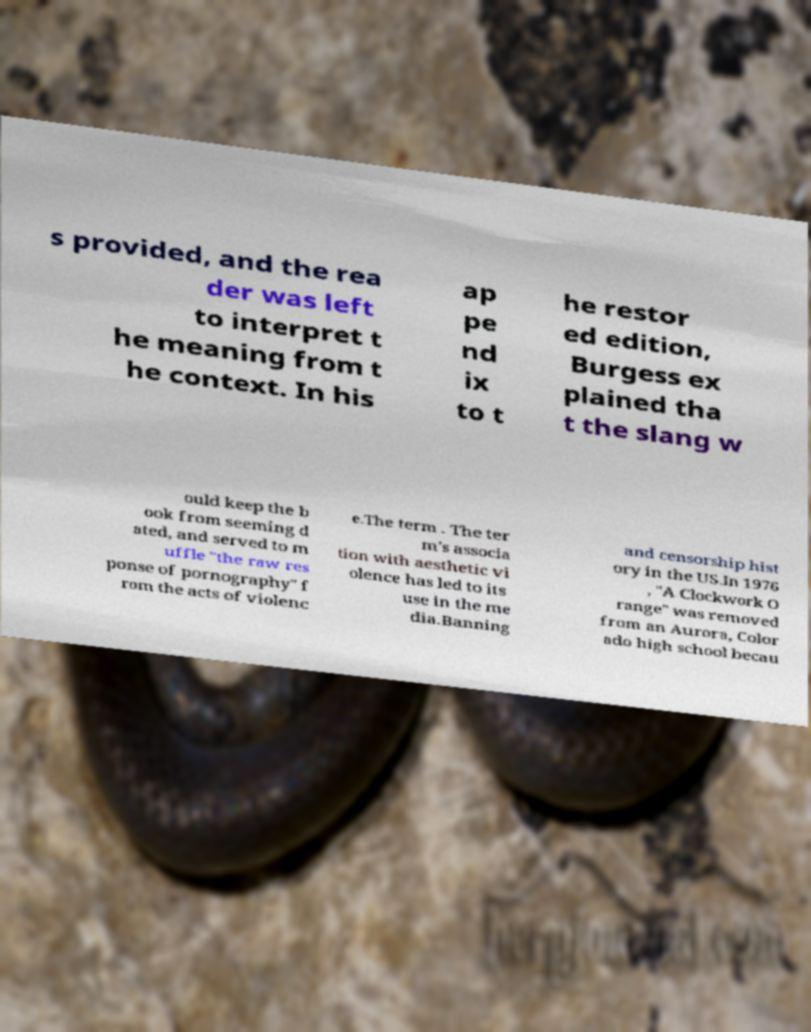There's text embedded in this image that I need extracted. Can you transcribe it verbatim? s provided, and the rea der was left to interpret t he meaning from t he context. In his ap pe nd ix to t he restor ed edition, Burgess ex plained tha t the slang w ould keep the b ook from seeming d ated, and served to m uffle "the raw res ponse of pornography" f rom the acts of violenc e.The term . The ter m's associa tion with aesthetic vi olence has led to its use in the me dia.Banning and censorship hist ory in the US.In 1976 , "A Clockwork O range" was removed from an Aurora, Color ado high school becau 